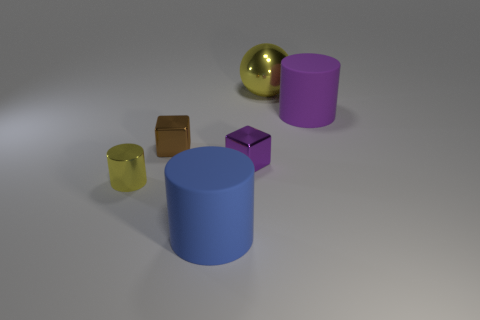Add 3 large green metallic cylinders. How many objects exist? 9 Subtract all balls. How many objects are left? 5 Add 5 small purple blocks. How many small purple blocks exist? 6 Subtract 0 brown balls. How many objects are left? 6 Subtract all large green things. Subtract all small cylinders. How many objects are left? 5 Add 1 blue cylinders. How many blue cylinders are left? 2 